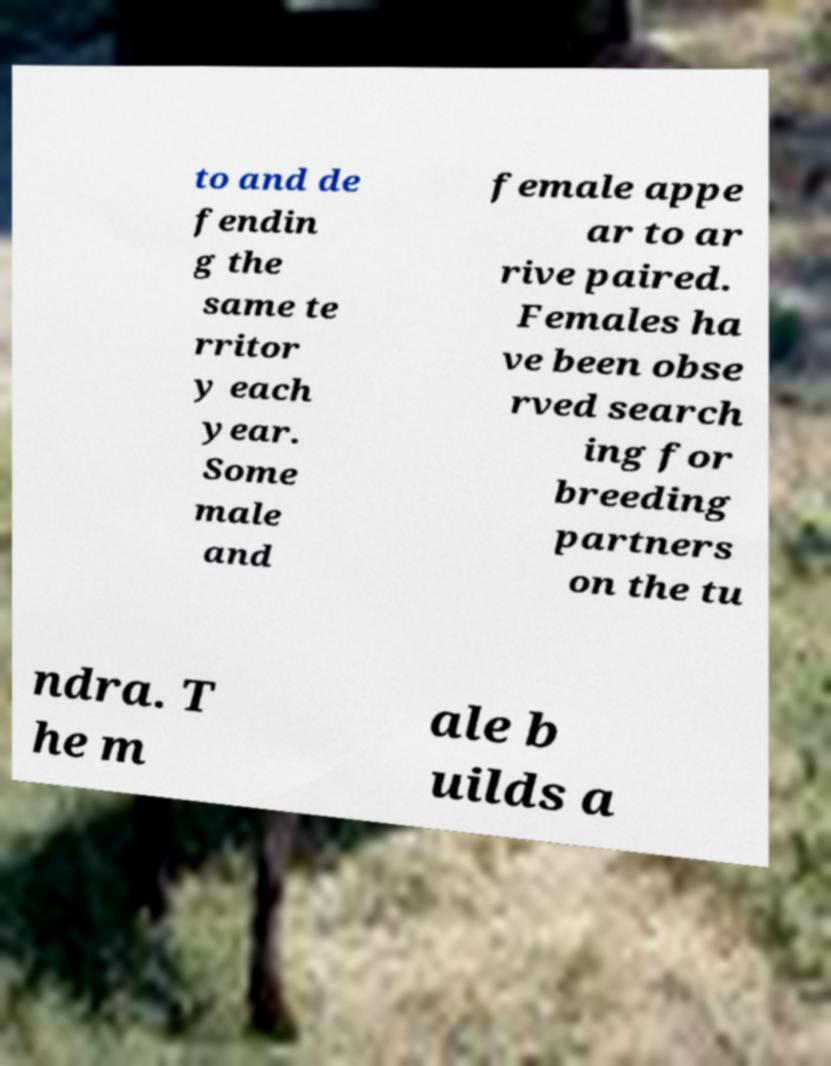For documentation purposes, I need the text within this image transcribed. Could you provide that? to and de fendin g the same te rritor y each year. Some male and female appe ar to ar rive paired. Females ha ve been obse rved search ing for breeding partners on the tu ndra. T he m ale b uilds a 